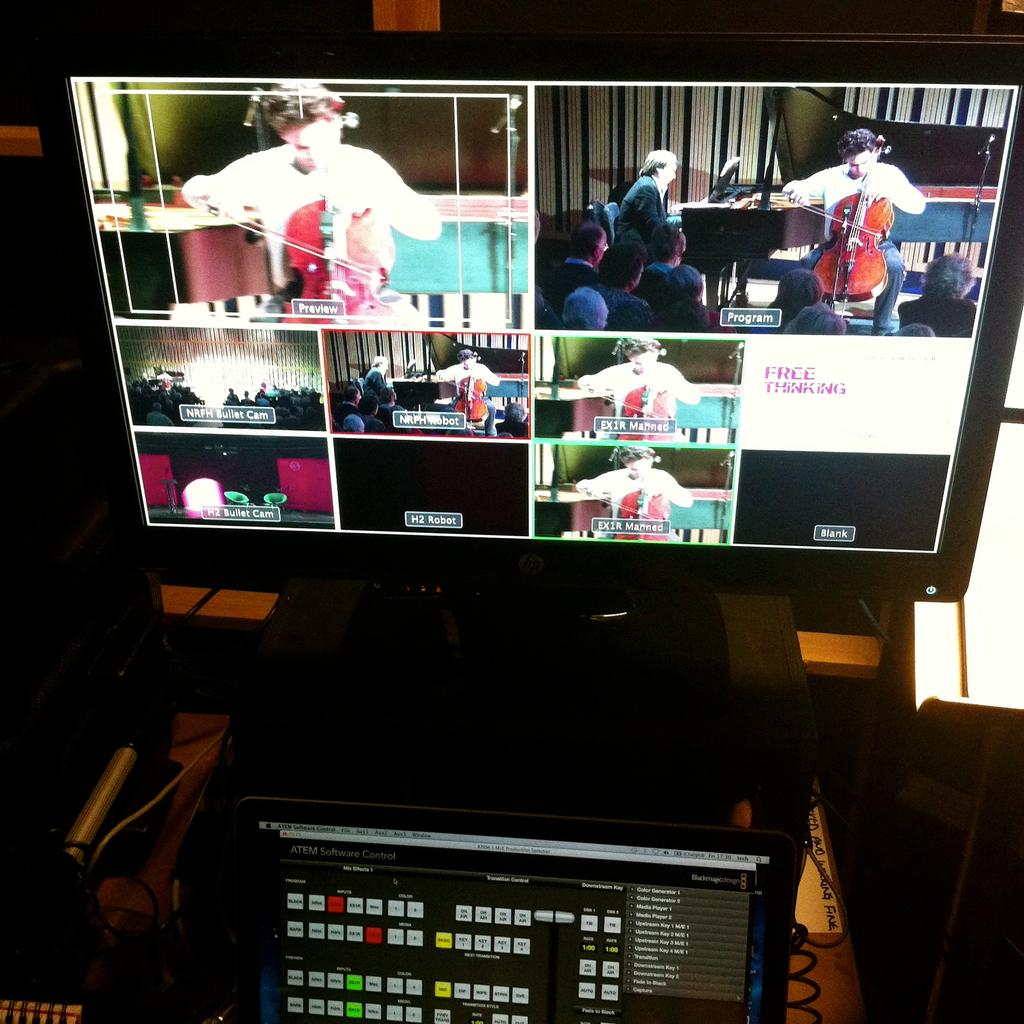<image>
Provide a brief description of the given image. A monitor displays a music recital with the text "Free Thinking" visible on the right. 